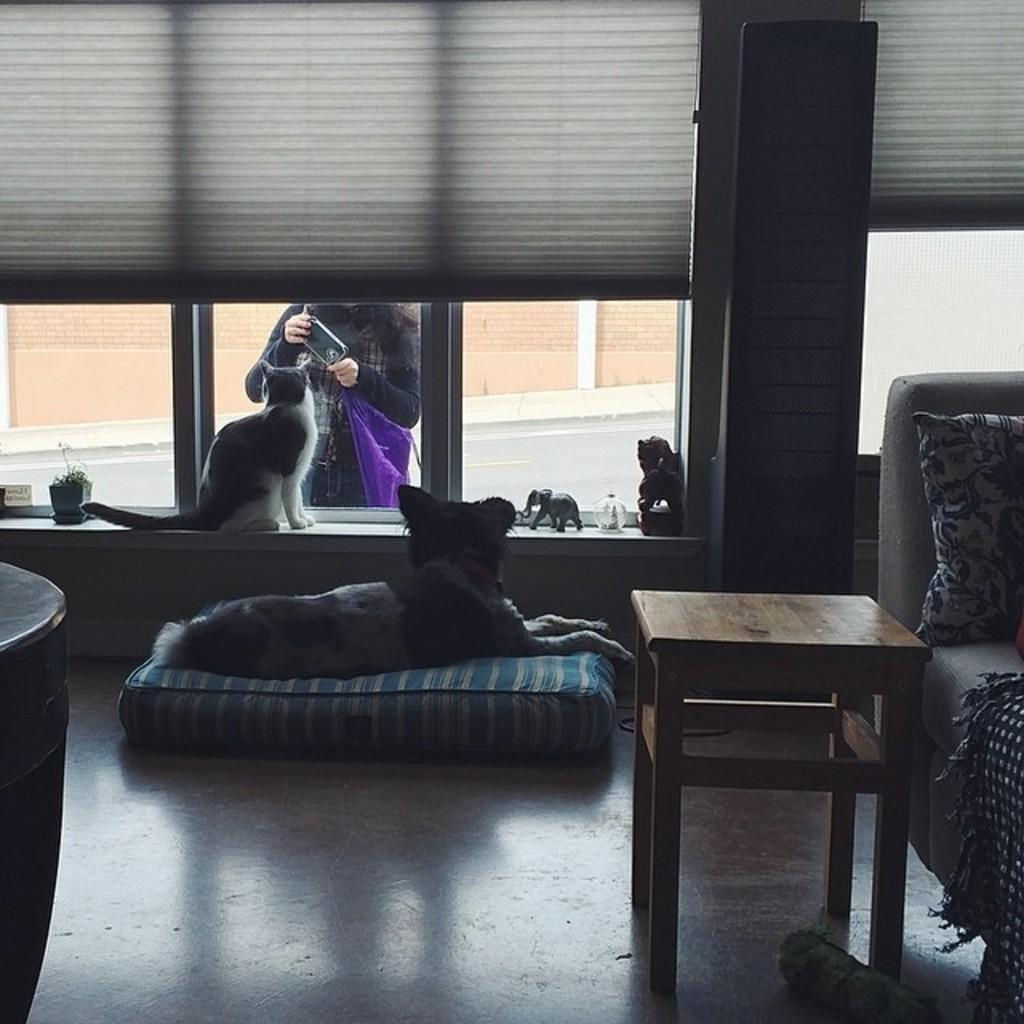What animals are present in the image? There is a dog and a cat in the image. What are the animals doing in the image? The dog and cat are sitting. Who else is present in the image? There is a woman in the image. What is the woman doing in the image? The woman is standing. What type of flesh can be seen on the cat's paw in the image? There is no flesh visible on the cat's paw in the image. What rhythm is the dog tapping its tail to in the image? The dog is sitting and not tapping its tail in the image. 